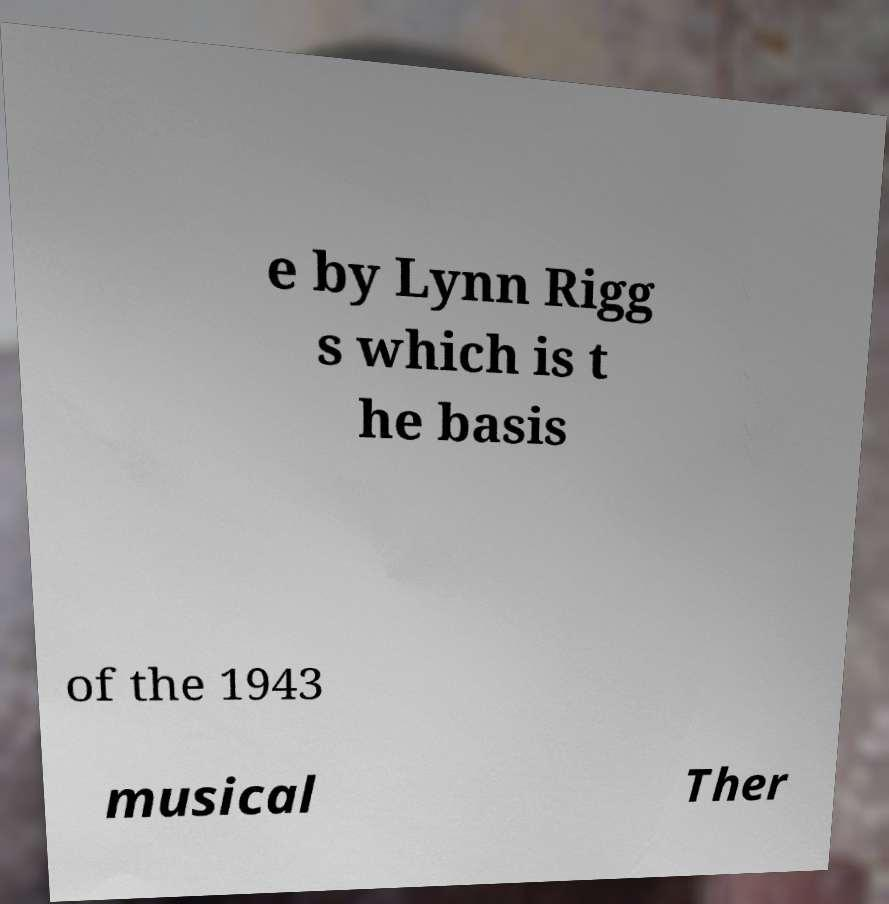Please identify and transcribe the text found in this image. e by Lynn Rigg s which is t he basis of the 1943 musical Ther 